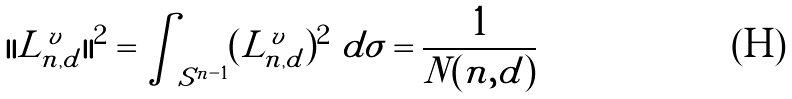<formula> <loc_0><loc_0><loc_500><loc_500>| | L ^ { v } _ { n , d } | | ^ { 2 } = \int _ { S ^ { n - 1 } } ( L ^ { v } _ { n , d } ) ^ { 2 } \ d \sigma = \frac { 1 } { N ( n , d ) }</formula> 